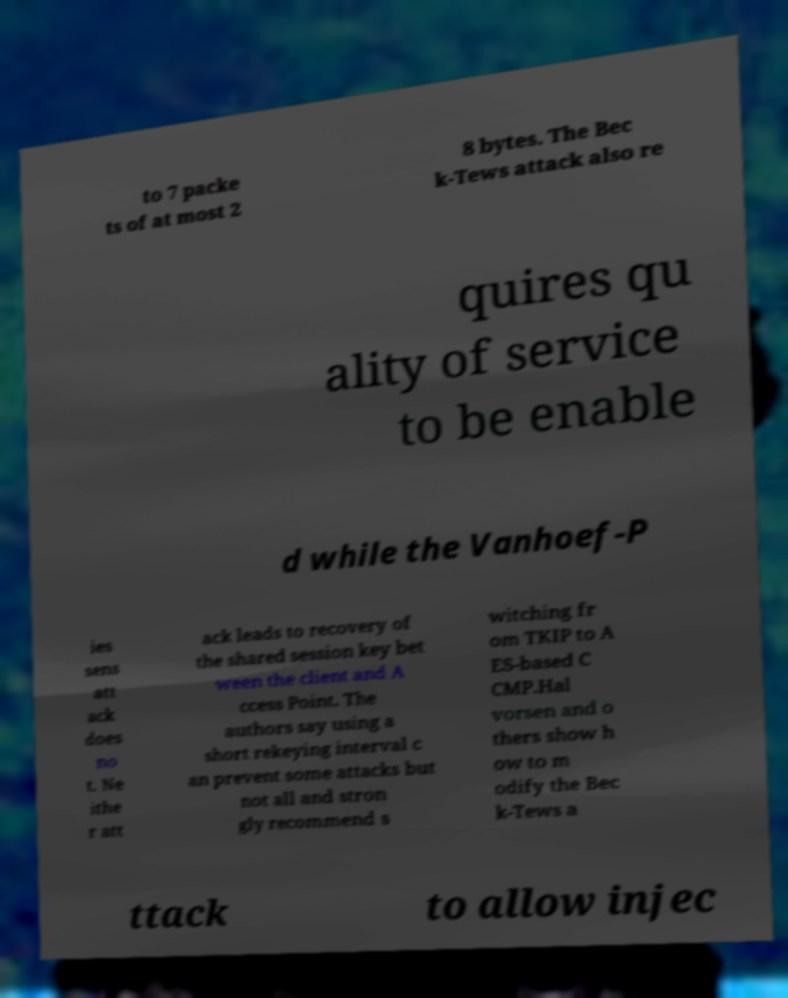Please read and relay the text visible in this image. What does it say? to 7 packe ts of at most 2 8 bytes. The Bec k-Tews attack also re quires qu ality of service to be enable d while the Vanhoef-P ies sens att ack does no t. Ne ithe r att ack leads to recovery of the shared session key bet ween the client and A ccess Point. The authors say using a short rekeying interval c an prevent some attacks but not all and stron gly recommend s witching fr om TKIP to A ES-based C CMP.Hal vorsen and o thers show h ow to m odify the Bec k-Tews a ttack to allow injec 